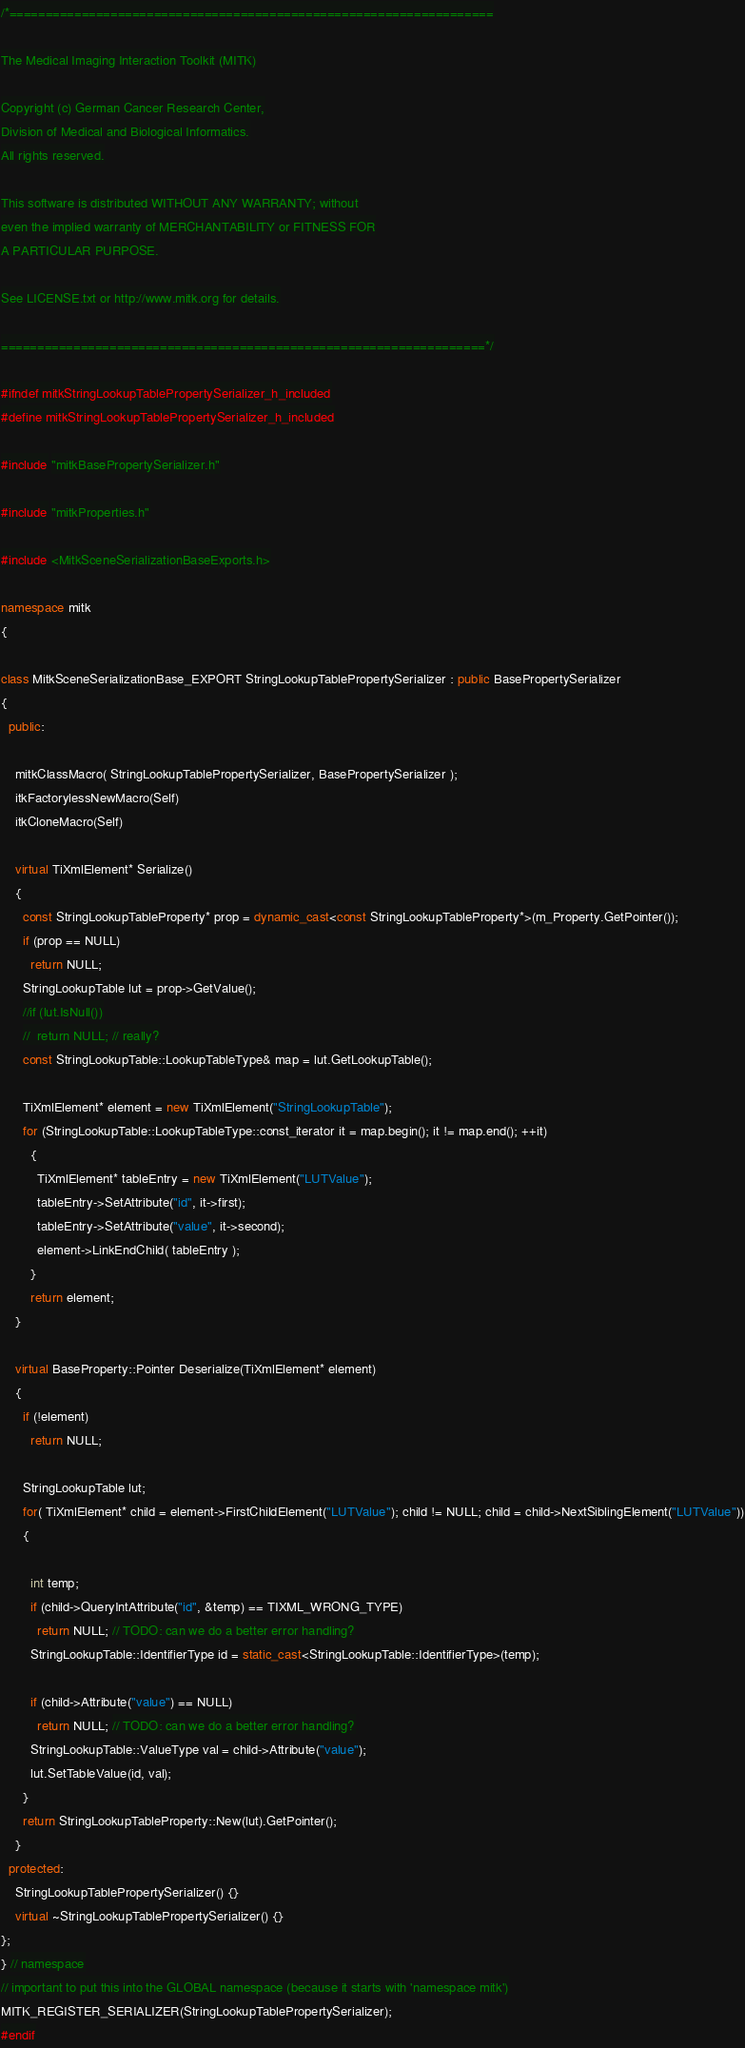<code> <loc_0><loc_0><loc_500><loc_500><_C++_>/*===================================================================

The Medical Imaging Interaction Toolkit (MITK)

Copyright (c) German Cancer Research Center,
Division of Medical and Biological Informatics.
All rights reserved.

This software is distributed WITHOUT ANY WARRANTY; without
even the implied warranty of MERCHANTABILITY or FITNESS FOR
A PARTICULAR PURPOSE.

See LICENSE.txt or http://www.mitk.org for details.

===================================================================*/

#ifndef mitkStringLookupTablePropertySerializer_h_included
#define mitkStringLookupTablePropertySerializer_h_included

#include "mitkBasePropertySerializer.h"

#include "mitkProperties.h"

#include <MitkSceneSerializationBaseExports.h>

namespace mitk
{

class MitkSceneSerializationBase_EXPORT StringLookupTablePropertySerializer : public BasePropertySerializer
{
  public:

    mitkClassMacro( StringLookupTablePropertySerializer, BasePropertySerializer );
    itkFactorylessNewMacro(Self)
    itkCloneMacro(Self)

    virtual TiXmlElement* Serialize()
    {
      const StringLookupTableProperty* prop = dynamic_cast<const StringLookupTableProperty*>(m_Property.GetPointer());
      if (prop == NULL)
        return NULL;
      StringLookupTable lut = prop->GetValue();
      //if (lut.IsNull())
      //  return NULL; // really?
      const StringLookupTable::LookupTableType& map = lut.GetLookupTable();

      TiXmlElement* element = new TiXmlElement("StringLookupTable");
      for (StringLookupTable::LookupTableType::const_iterator it = map.begin(); it != map.end(); ++it)
        {
          TiXmlElement* tableEntry = new TiXmlElement("LUTValue");
          tableEntry->SetAttribute("id", it->first);
          tableEntry->SetAttribute("value", it->second);
          element->LinkEndChild( tableEntry );
        }
        return element;
    }

    virtual BaseProperty::Pointer Deserialize(TiXmlElement* element)
    {
      if (!element)
        return NULL;

      StringLookupTable lut;
      for( TiXmlElement* child = element->FirstChildElement("LUTValue"); child != NULL; child = child->NextSiblingElement("LUTValue"))
      {

        int temp;
        if (child->QueryIntAttribute("id", &temp) == TIXML_WRONG_TYPE)
          return NULL; // TODO: can we do a better error handling?
        StringLookupTable::IdentifierType id = static_cast<StringLookupTable::IdentifierType>(temp);

        if (child->Attribute("value") == NULL)
          return NULL; // TODO: can we do a better error handling?
        StringLookupTable::ValueType val = child->Attribute("value");
        lut.SetTableValue(id, val);
      }
      return StringLookupTableProperty::New(lut).GetPointer();
    }
  protected:
    StringLookupTablePropertySerializer() {}
    virtual ~StringLookupTablePropertySerializer() {}
};
} // namespace
// important to put this into the GLOBAL namespace (because it starts with 'namespace mitk')
MITK_REGISTER_SERIALIZER(StringLookupTablePropertySerializer);
#endif
</code> 